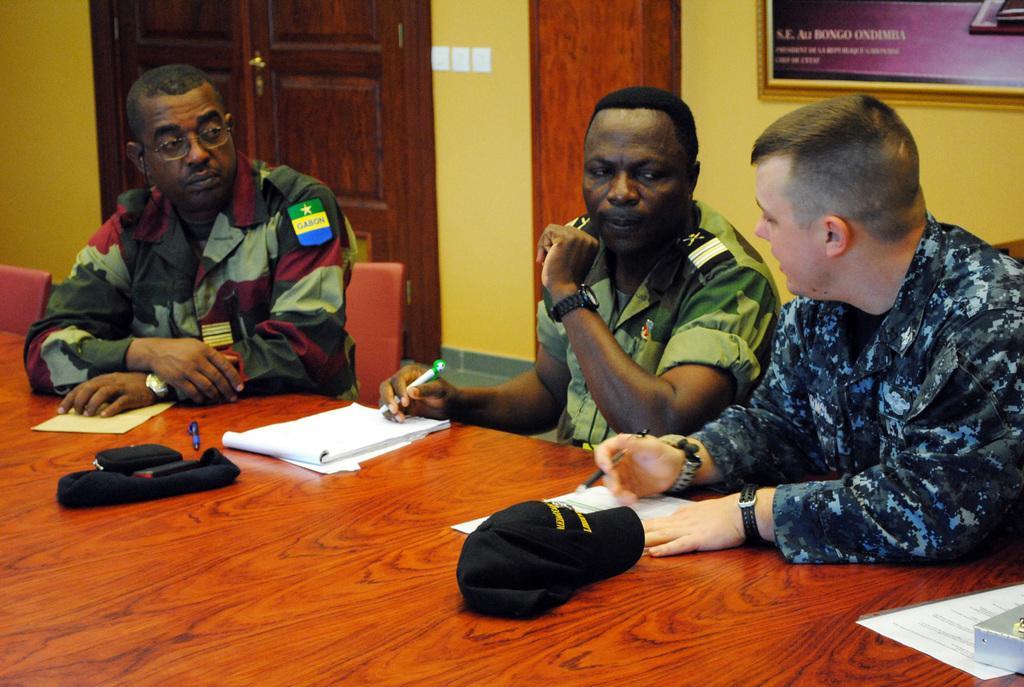Describe this image in one or two sentences. In this picture we can see there are three people sitting on chairs and two people holding the pens. In front of the people there is a table and on the table there is a cap, papers, pen, book and some objects. Behind the people there is a wall with photo frames, switches and a wooden door. 